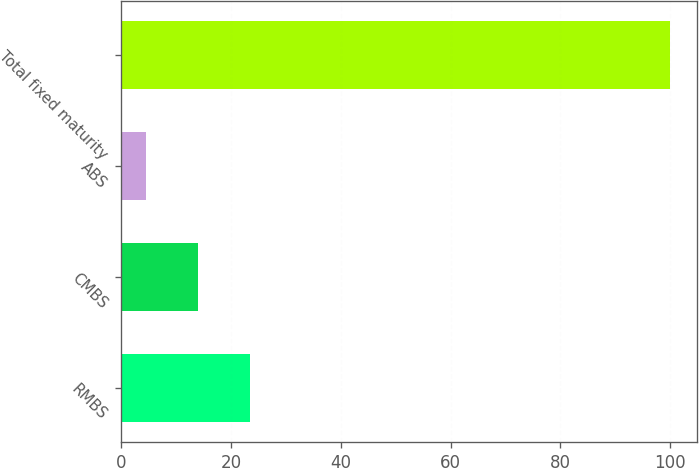Convert chart. <chart><loc_0><loc_0><loc_500><loc_500><bar_chart><fcel>RMBS<fcel>CMBS<fcel>ABS<fcel>Total fixed maturity<nl><fcel>23.52<fcel>13.96<fcel>4.4<fcel>100<nl></chart> 